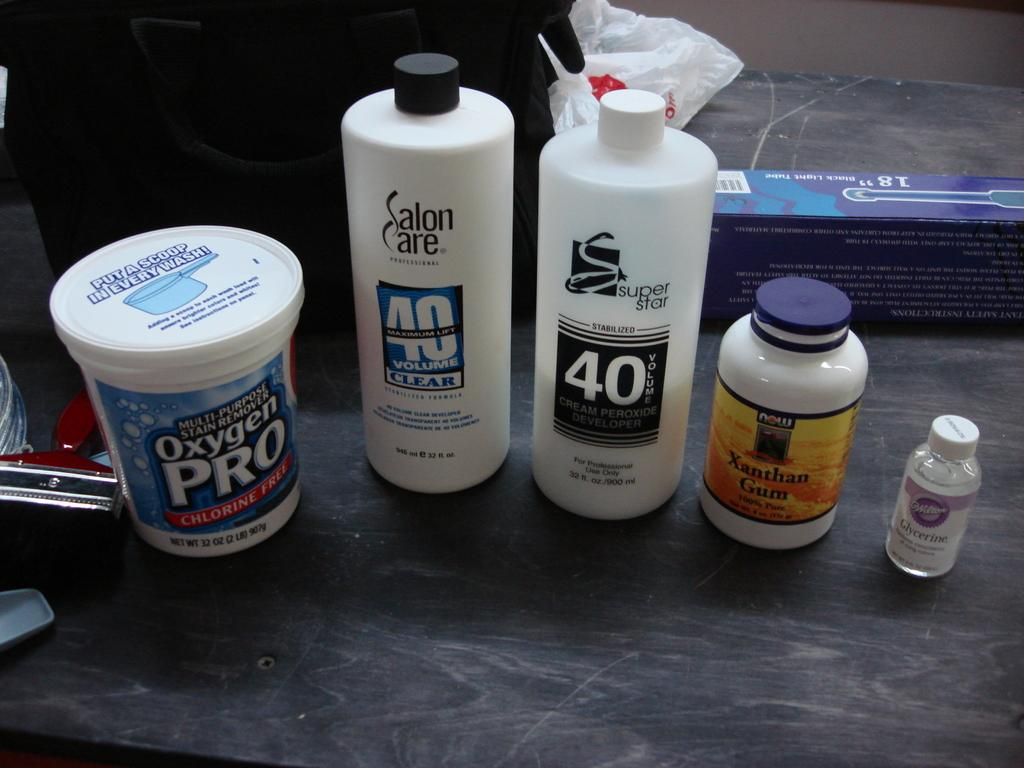<image>
Present a compact description of the photo's key features. 5 bottles, one of which is Xanthan Gum sit on a black wood like surface. 